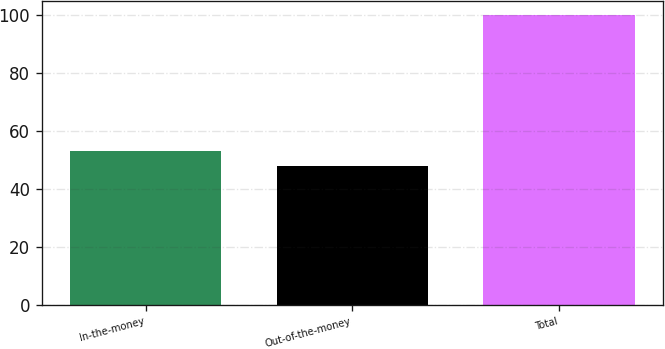Convert chart. <chart><loc_0><loc_0><loc_500><loc_500><bar_chart><fcel>In-the-money<fcel>Out-of-the-money<fcel>Total<nl><fcel>53.2<fcel>48<fcel>100<nl></chart> 